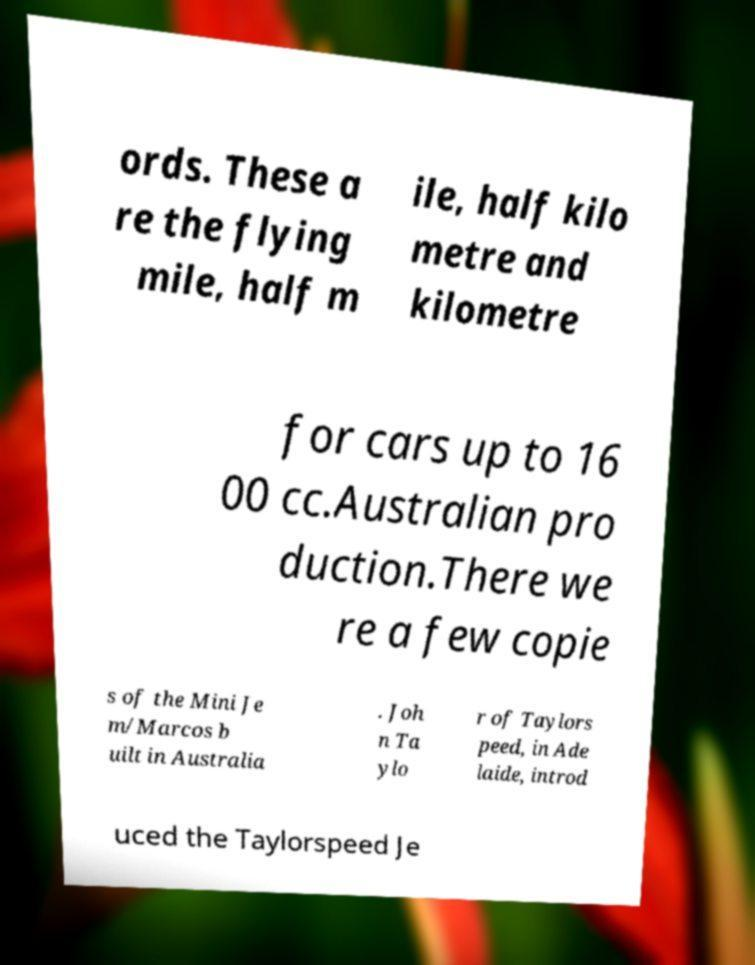Could you assist in decoding the text presented in this image and type it out clearly? ords. These a re the flying mile, half m ile, half kilo metre and kilometre for cars up to 16 00 cc.Australian pro duction.There we re a few copie s of the Mini Je m/Marcos b uilt in Australia . Joh n Ta ylo r of Taylors peed, in Ade laide, introd uced the Taylorspeed Je 